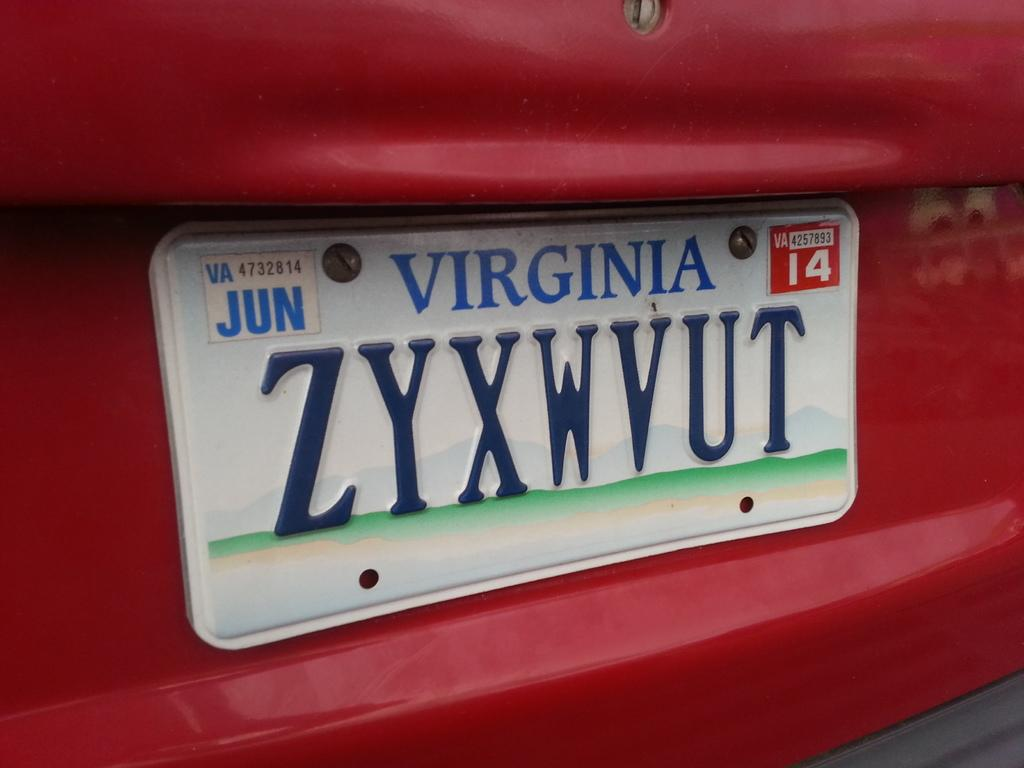<image>
Render a clear and concise summary of the photo. a virginia license plate that is on a car 